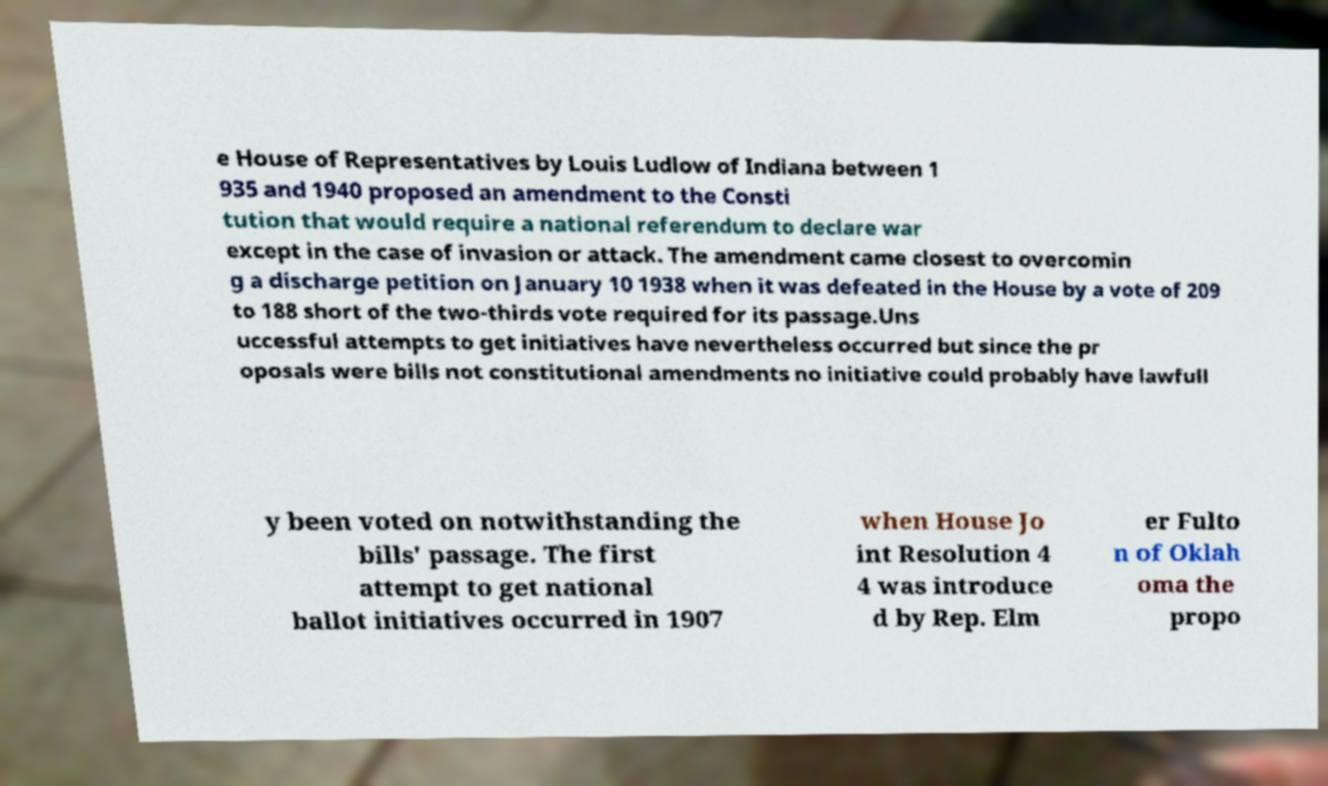What messages or text are displayed in this image? I need them in a readable, typed format. e House of Representatives by Louis Ludlow of Indiana between 1 935 and 1940 proposed an amendment to the Consti tution that would require a national referendum to declare war except in the case of invasion or attack. The amendment came closest to overcomin g a discharge petition on January 10 1938 when it was defeated in the House by a vote of 209 to 188 short of the two-thirds vote required for its passage.Uns uccessful attempts to get initiatives have nevertheless occurred but since the pr oposals were bills not constitutional amendments no initiative could probably have lawfull y been voted on notwithstanding the bills' passage. The first attempt to get national ballot initiatives occurred in 1907 when House Jo int Resolution 4 4 was introduce d by Rep. Elm er Fulto n of Oklah oma the propo 